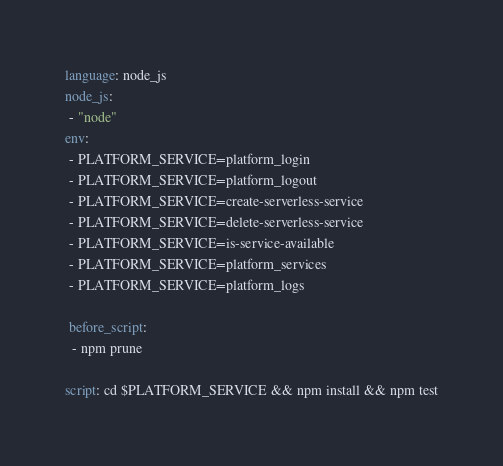<code> <loc_0><loc_0><loc_500><loc_500><_YAML_>language: node_js
node_js:
 - "node"
env:
 - PLATFORM_SERVICE=platform_login
 - PLATFORM_SERVICE=platform_logout
 - PLATFORM_SERVICE=create-serverless-service
 - PLATFORM_SERVICE=delete-serverless-service
 - PLATFORM_SERVICE=is-service-available
 - PLATFORM_SERVICE=platform_services
 - PLATFORM_SERVICE=platform_logs

 before_script:
  - npm prune
  
script: cd $PLATFORM_SERVICE && npm install && npm test
</code> 